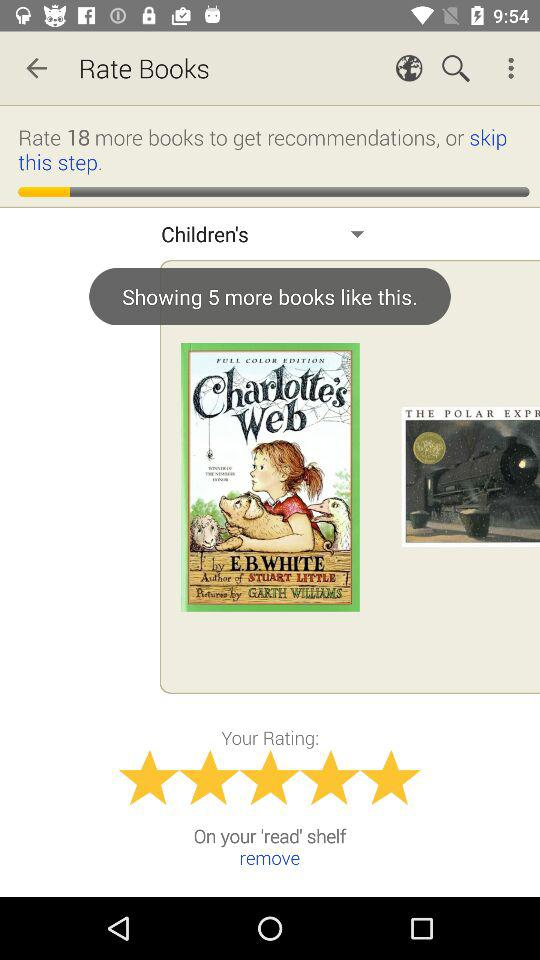What is the rating of "Charlotte's Web"? The rating is 5 stars. 